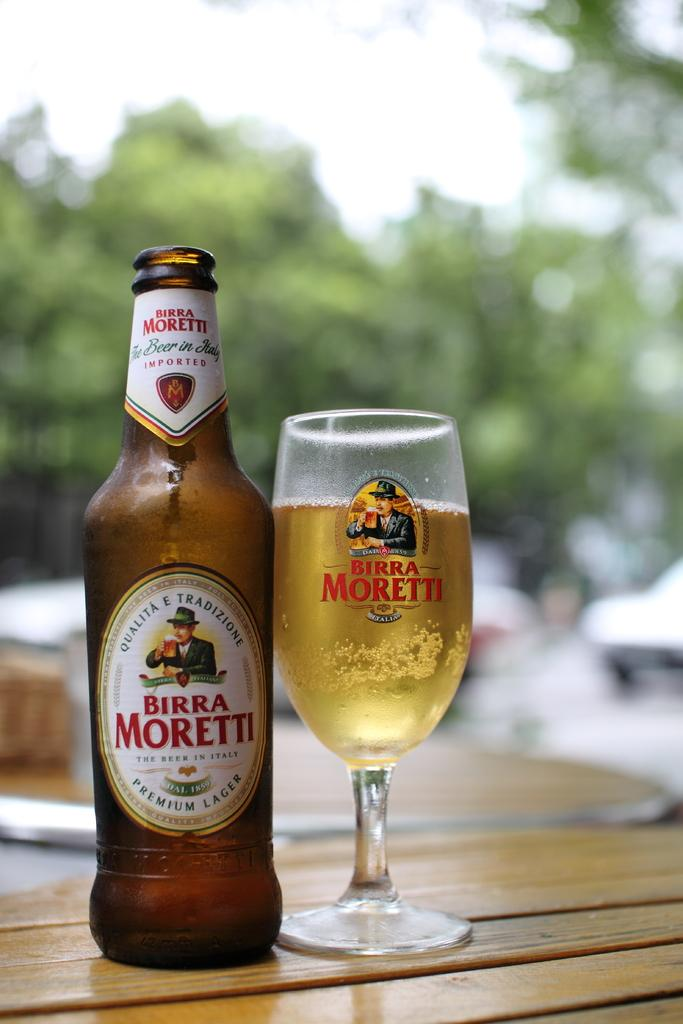<image>
Relay a brief, clear account of the picture shown. A bottle of Birra Moretti poured into a Birra Moretti glass next to it. 